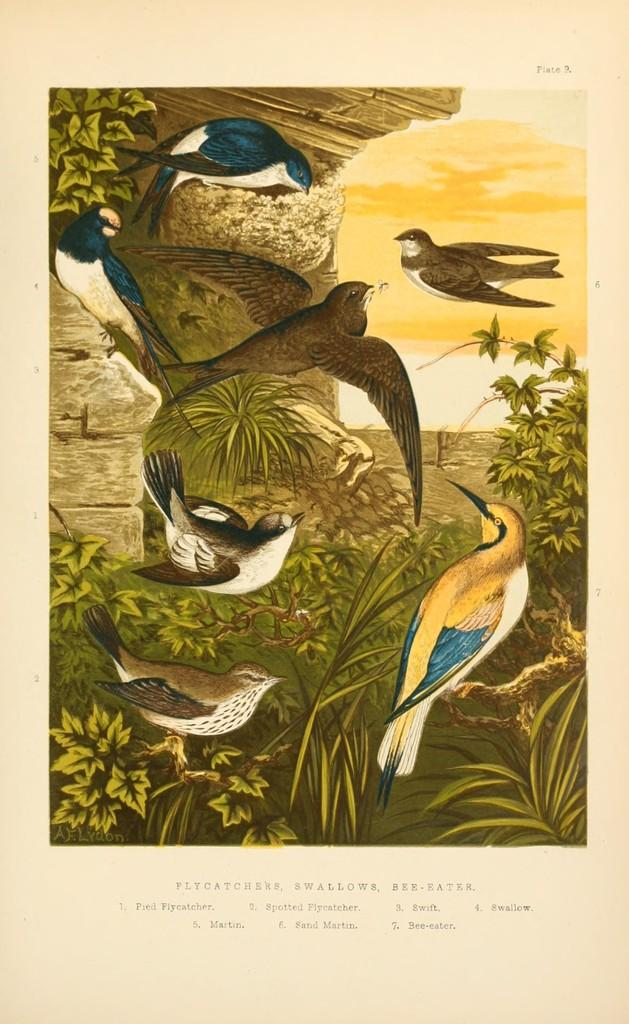What type of visual is depicted in the image? The image appears to be a poster. What can be seen in the middle of the poster? There are birds and plants in the middle of the poster. Is there any text or writing on the poster? Yes, there is text or writing at the bottom of the poster. What type of wound can be seen on the bird in the image? There is no wound visible on the bird in the image. Can you tell me how many volleyballs are present in the image? There are no volleyballs present in the image. 